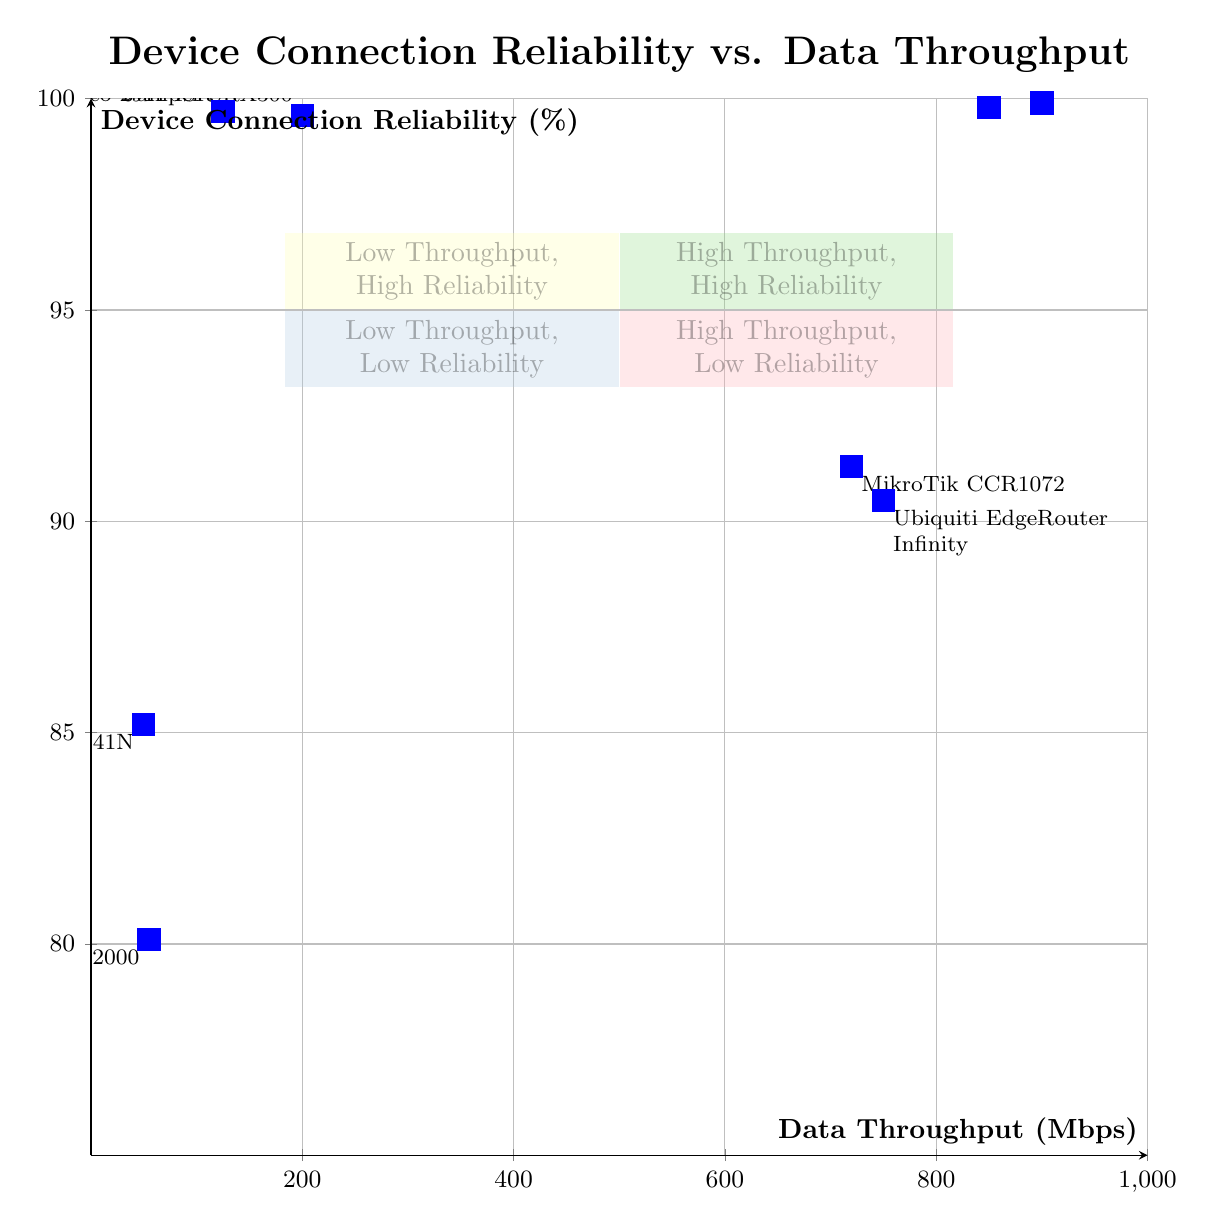What are the X and Y values for Cisco Nexus 9000? According to the diagram, the X value (Data Throughput) for Cisco Nexus 9000 is 900 Mbps, and the Y value (Device Connection Reliability) is 99.9%.
Answer: 900 Mbps, 99.9% Which device has the lowest connection reliability? By inspecting the diagram and identifying the lowest point on the Y-axis, it is evident that TP-Link TL-WR841N has the lowest connection reliability at 85.2%.
Answer: TP-Link TL-WR841N How many devices are in the High Throughput, Low Reliability quadrant? There are two devices found in the High Throughput, Low Reliability quadrant: Ubiquiti EdgeRouter Infinity and MikroTik CCR1072.
Answer: 2 What is the connection reliability percentage for Juniper MX960? The diagram indicates that the connection reliability percentage for Juniper MX960 is 99.8%.
Answer: 99.8% Determine the quadrant where Cisco 2911 ISR is located. Analyzing the diagram, Cisco 2911 ISR, with a throughput of 125 Mbps and a reliability of 99.7%, is located in the Low Throughput, High Reliability quadrant.
Answer: Low Throughput, High Reliability Which device has a Data Throughput of 55 Mbps? Looking at the data points in the diagram, the device with a Data Throughput of 55 Mbps is Netgear WNR2000.
Answer: Netgear WNR2000 What distinguishes the High Throughput, High Reliability quadrant from others? This quadrant is characterized by devices that exhibit both high data rates (above 600 Mbps) and excellent connection reliability (above 98%). In specific terms, it contains devices like Cisco Nexus 9000 and Juniper MX960.
Answer: High Data Rates and Excellent Reliability What is the highest data throughput shown in the diagram? Upon reviewing the X-axis of the diagram, the highest data throughput is 900 Mbps, as represented by the Cisco Nexus 9000.
Answer: 900 Mbps 